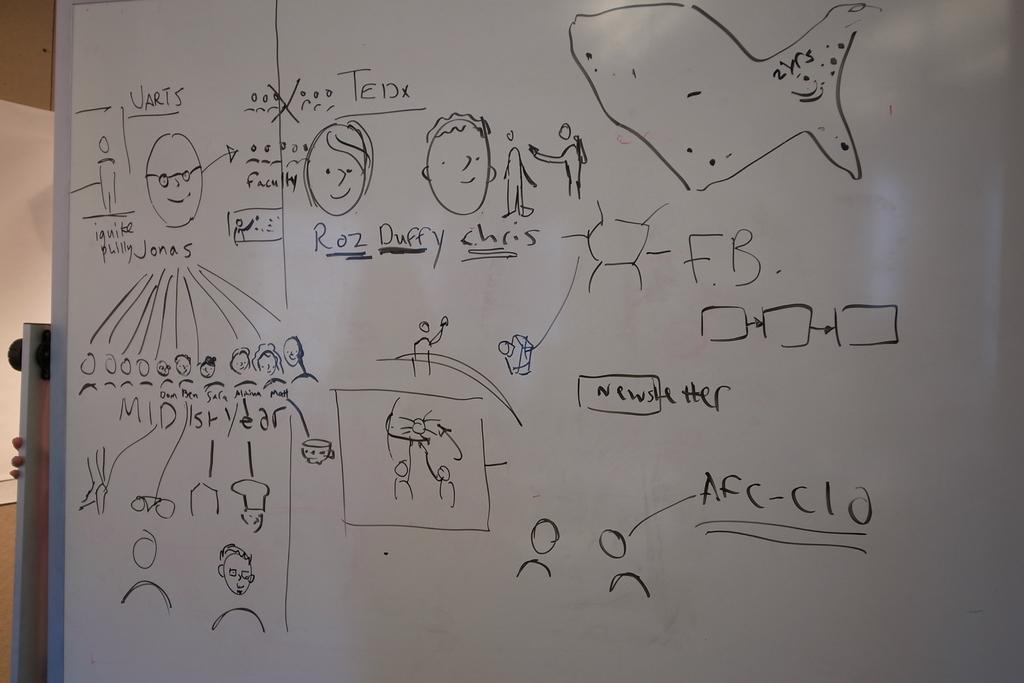<image>
Describe the image concisely. A white board is written and drawn on and has the word newsletter towards the middle. 